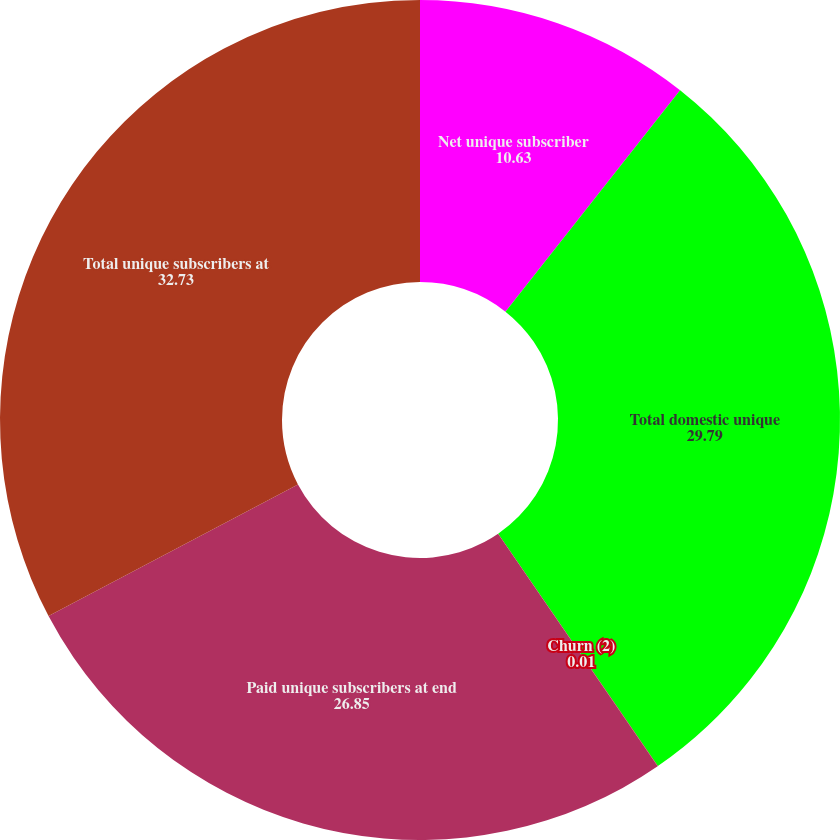Convert chart. <chart><loc_0><loc_0><loc_500><loc_500><pie_chart><fcel>Net unique subscriber<fcel>Total domestic unique<fcel>Churn (2)<fcel>Paid unique subscribers at end<fcel>Total unique subscribers at<nl><fcel>10.63%<fcel>29.79%<fcel>0.01%<fcel>26.85%<fcel>32.73%<nl></chart> 